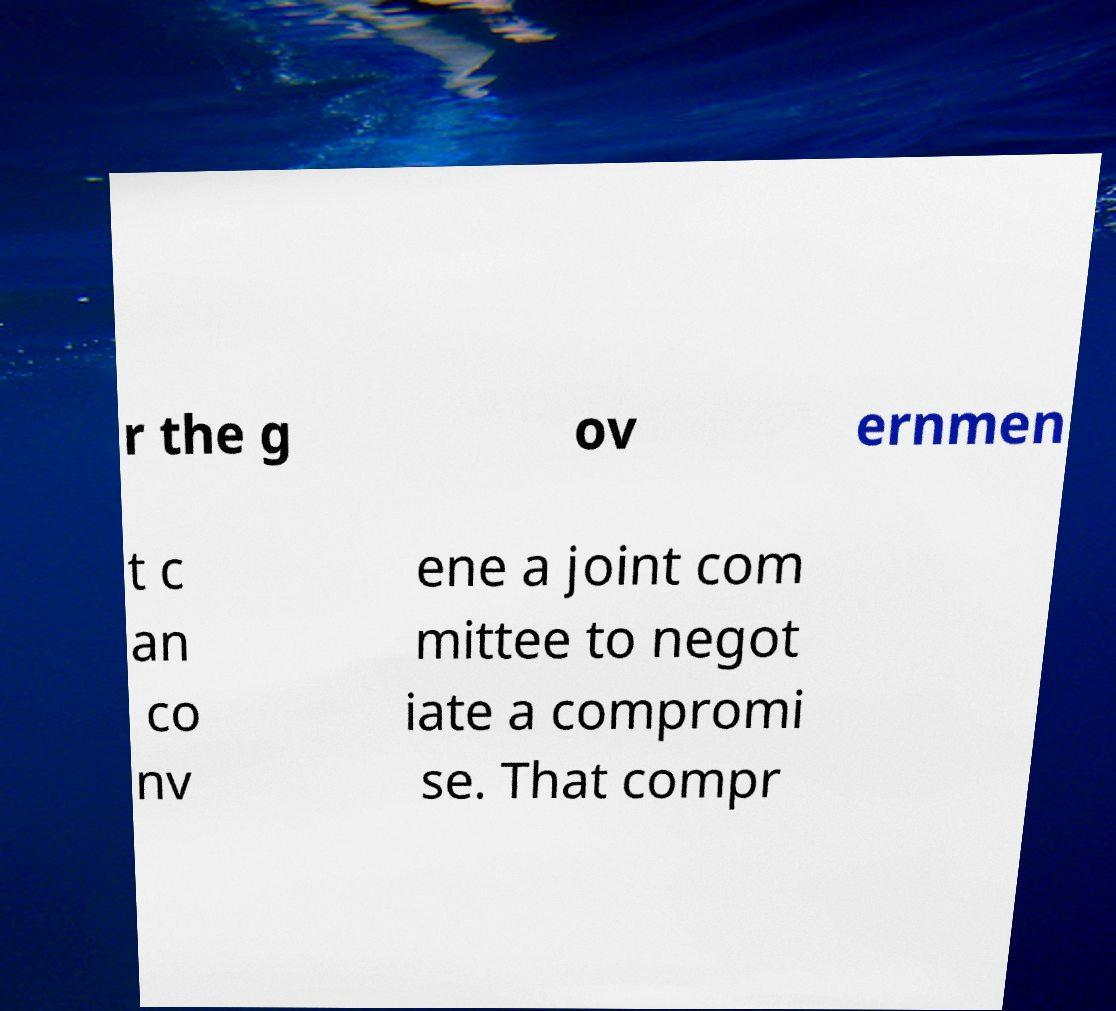There's text embedded in this image that I need extracted. Can you transcribe it verbatim? r the g ov ernmen t c an co nv ene a joint com mittee to negot iate a compromi se. That compr 